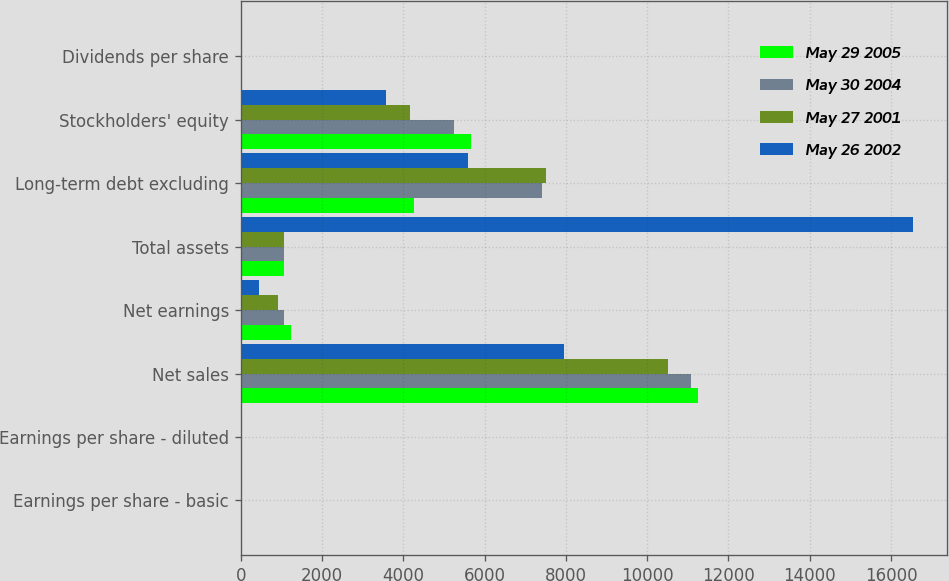Convert chart to OTSL. <chart><loc_0><loc_0><loc_500><loc_500><stacked_bar_chart><ecel><fcel>Earnings per share - basic<fcel>Earnings per share - diluted<fcel>Net sales<fcel>Net earnings<fcel>Total assets<fcel>Long-term debt excluding<fcel>Stockholders' equity<fcel>Dividends per share<nl><fcel>May 29 2005<fcel>3.34<fcel>3.08<fcel>11244<fcel>1240<fcel>1055<fcel>4255<fcel>5676<fcel>1.24<nl><fcel>May 30 2004<fcel>2.82<fcel>2.6<fcel>11070<fcel>1055<fcel>1055<fcel>7410<fcel>5248<fcel>1.1<nl><fcel>May 27 2001<fcel>2.49<fcel>2.35<fcel>10506<fcel>917<fcel>1055<fcel>7516<fcel>4175<fcel>1.1<nl><fcel>May 26 2002<fcel>1.38<fcel>1.34<fcel>7949<fcel>458<fcel>16540<fcel>5591<fcel>3576<fcel>1.1<nl></chart> 